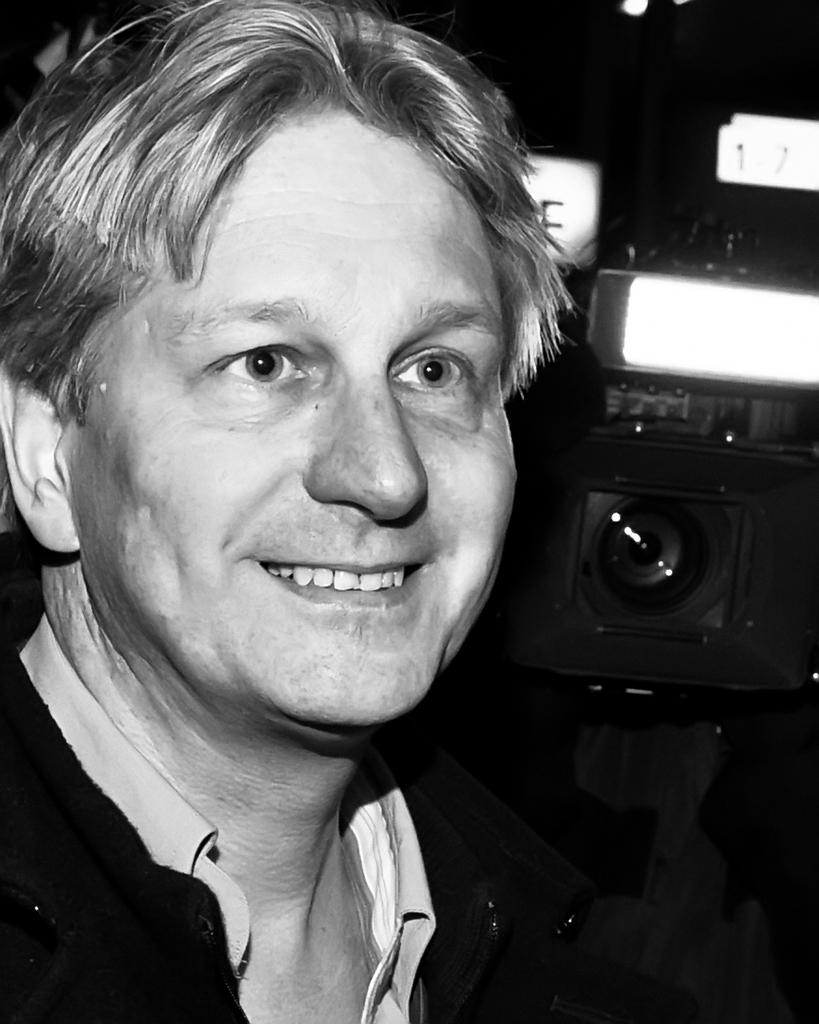Who is present in the image? There is a man in the image. What can be observed about the background of the image? The background of the image is dark. How many friends are present on the farm in the image? There is no mention of friends or a farm in the image; it only features a man with a dark background. 